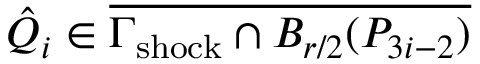Convert formula to latex. <formula><loc_0><loc_0><loc_500><loc_500>\hat { Q } _ { i } \in \overline { { \Gamma _ { s h o c k } \cap B _ { r / 2 } ( P _ { 3 i - 2 } ) } }</formula> 